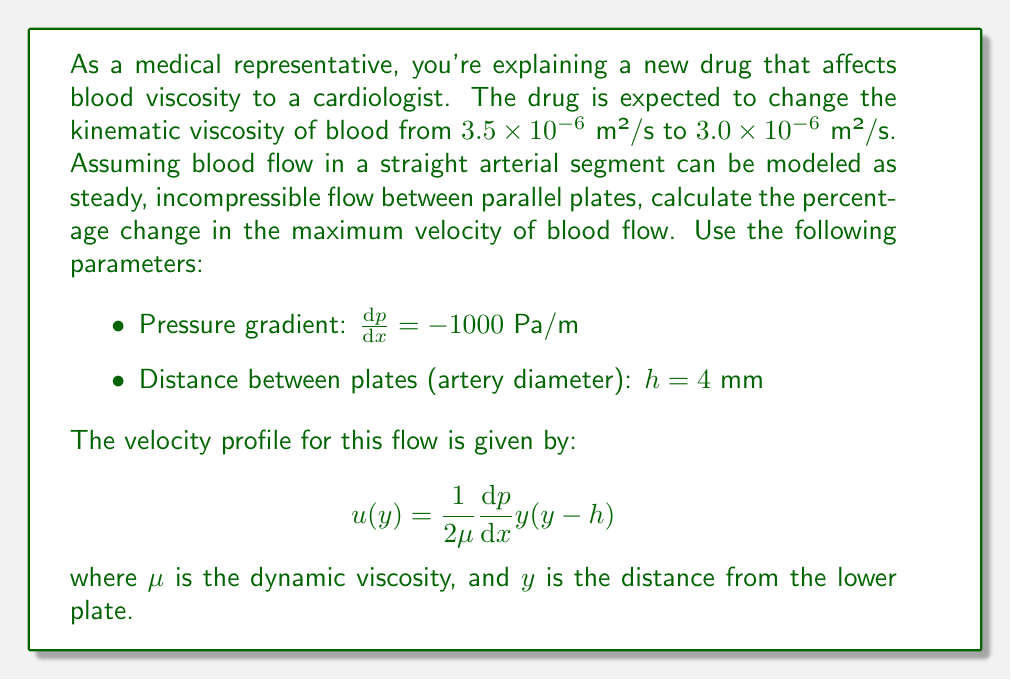Provide a solution to this math problem. Let's approach this step-by-step:

1) First, we need to find the maximum velocity. This occurs at the center of the flow, where $y = \frac{h}{2}$. Substituting this into the velocity profile equation:

   $$ u_{max} = \frac{1}{2\mu}\frac{dp}{dx}\frac{h}{2}(\frac{h}{2}-h) = -\frac{1}{8\mu}\frac{dp}{dx}h^2 $$

2) We're given the kinematic viscosity $\nu$, but we need the dynamic viscosity $\mu$. They're related by $\mu = \rho\nu$, where $\rho$ is the density of blood. However, we don't need to know $\rho$ because it will cancel out in our final calculation.

3) Let's call the initial maximum velocity $u_1$ and the final maximum velocity $u_2$. Then:

   $$ u_1 = -\frac{1}{8\rho\nu_1}\frac{dp}{dx}h^2 $$
   $$ u_2 = -\frac{1}{8\rho\nu_2}\frac{dp}{dx}h^2 $$

4) The percentage change is given by:

   $$ \text{Percentage Change} = \frac{u_2 - u_1}{u_1} \times 100\% $$

5) Substituting the expressions for $u_1$ and $u_2$:

   $$ \text{Percentage Change} = \frac{(-\frac{1}{8\rho\nu_2}\frac{dp}{dx}h^2) - (-\frac{1}{8\rho\nu_1}\frac{dp}{dx}h^2)}{-\frac{1}{8\rho\nu_1}\frac{dp}{dx}h^2} \times 100\% $$

6) The $-\frac{1}{8\rho}\frac{dp}{dx}h^2$ terms cancel out, leaving:

   $$ \text{Percentage Change} = \frac{\frac{1}{\nu_2} - \frac{1}{\nu_1}}{\frac{1}{\nu_1}} \times 100\% = (\frac{\nu_1}{\nu_2} - 1) \times 100\% $$

7) Now we can substitute the values:

   $$ \text{Percentage Change} = (\frac{3.5 \times 10^{-6}}{3.0 \times 10^{-6}} - 1) \times 100\% $$
   $$ = (1.1667 - 1) \times 100\% = 0.1667 \times 100\% = 16.67\% $$

Thus, the maximum velocity increases by approximately 16.67%.
Answer: 16.67% increase 